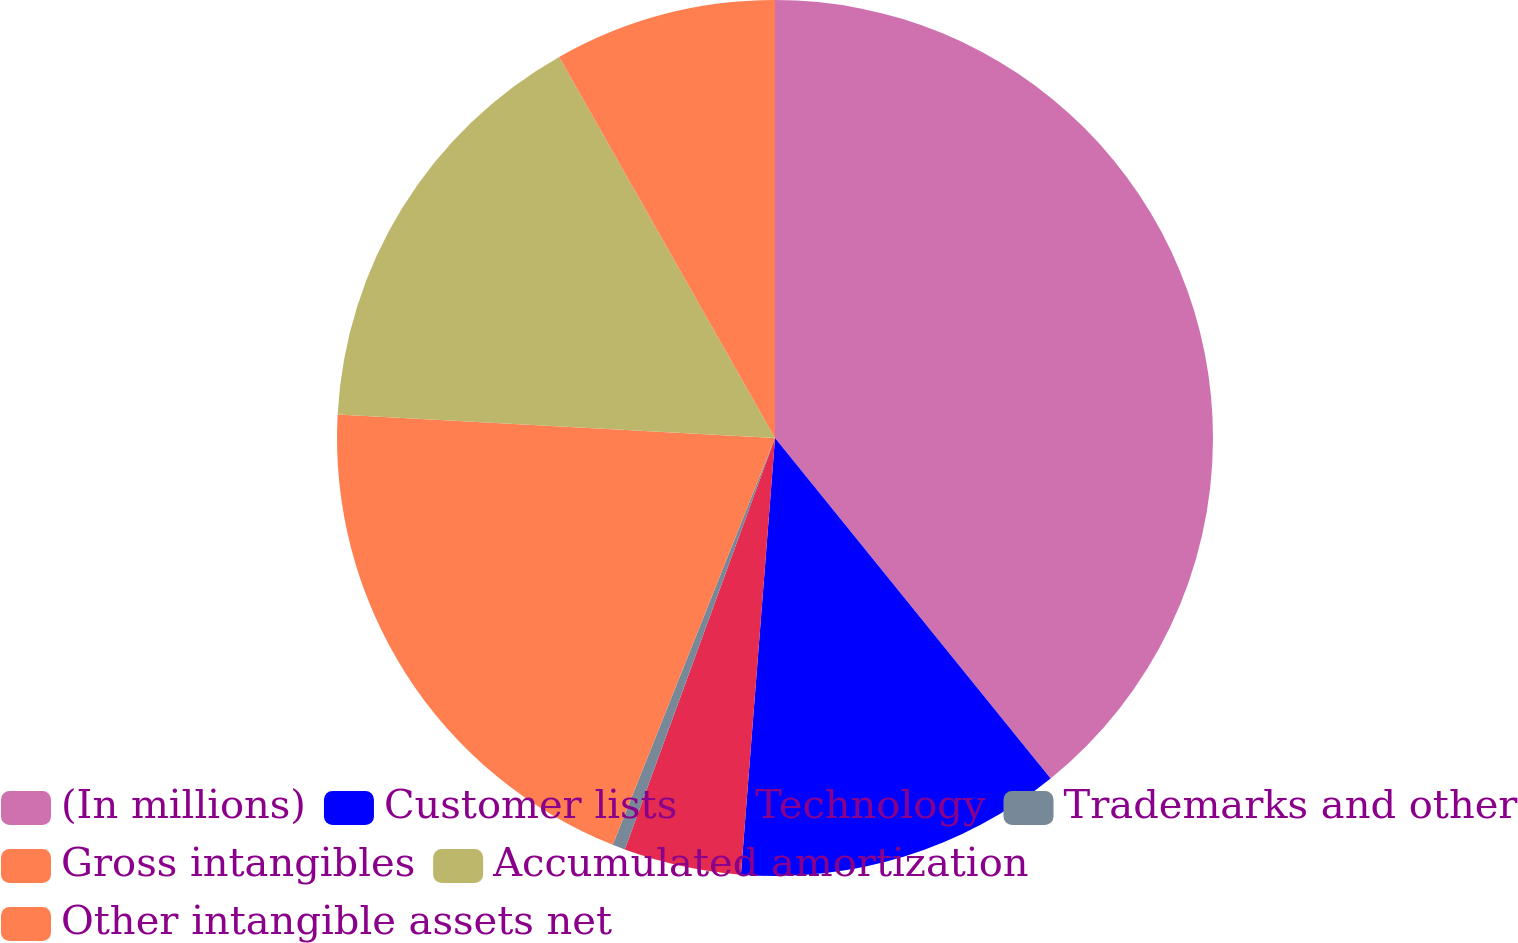Convert chart to OTSL. <chart><loc_0><loc_0><loc_500><loc_500><pie_chart><fcel>(In millions)<fcel>Customer lists<fcel>Technology<fcel>Trademarks and other<fcel>Gross intangibles<fcel>Accumulated amortization<fcel>Other intangible assets net<nl><fcel>39.16%<fcel>12.07%<fcel>4.33%<fcel>0.47%<fcel>19.81%<fcel>15.94%<fcel>8.2%<nl></chart> 